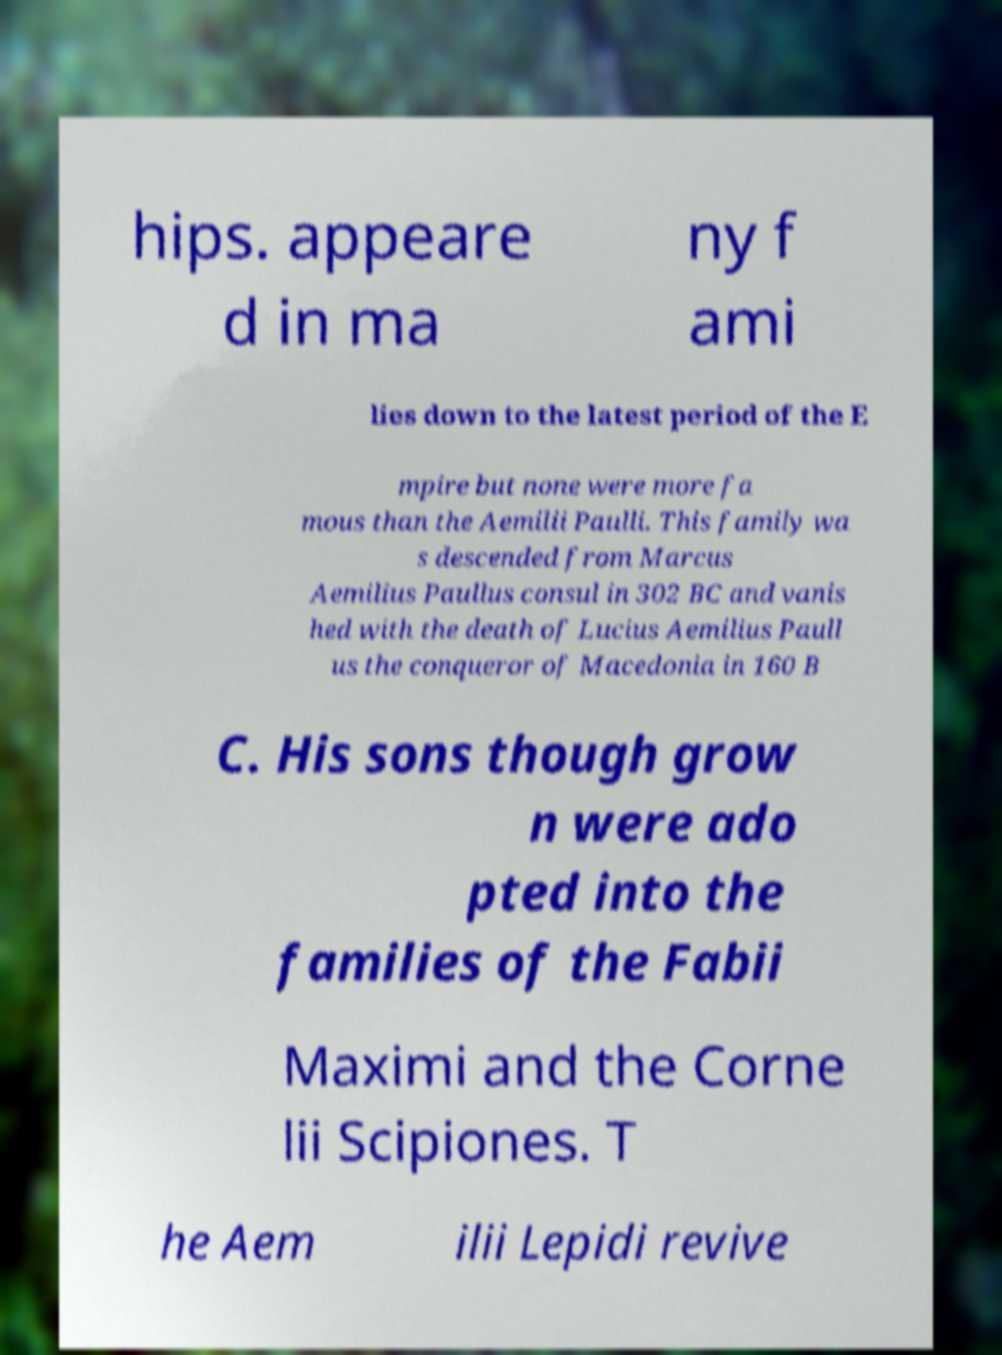For documentation purposes, I need the text within this image transcribed. Could you provide that? hips. appeare d in ma ny f ami lies down to the latest period of the E mpire but none were more fa mous than the Aemilii Paulli. This family wa s descended from Marcus Aemilius Paullus consul in 302 BC and vanis hed with the death of Lucius Aemilius Paull us the conqueror of Macedonia in 160 B C. His sons though grow n were ado pted into the families of the Fabii Maximi and the Corne lii Scipiones. T he Aem ilii Lepidi revive 